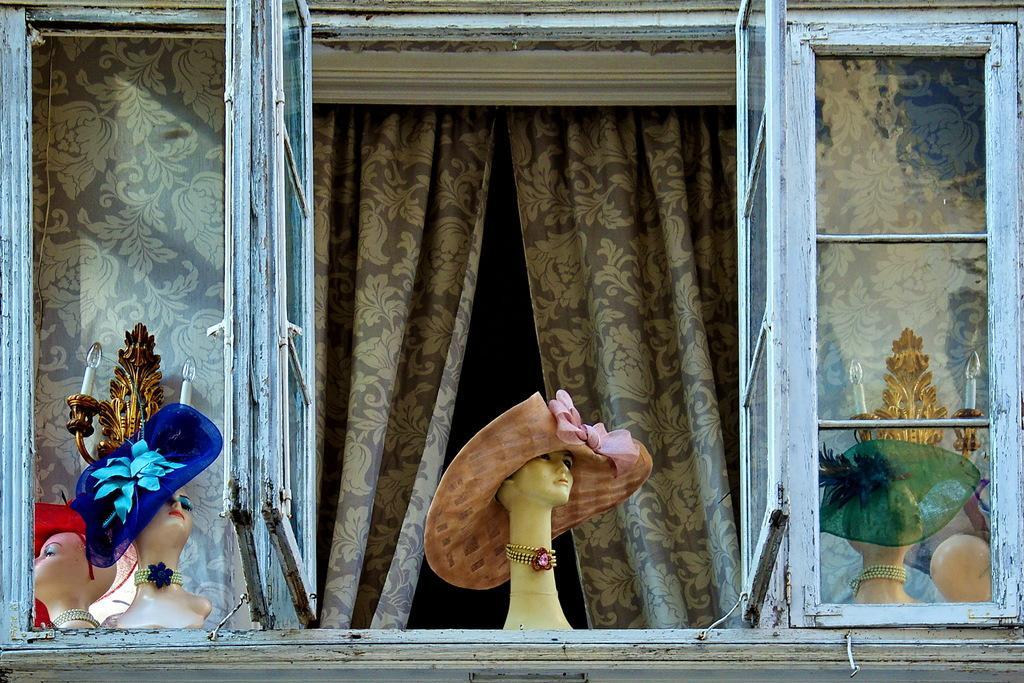Please provide a concise description of this image. In this picture we can see few mannequins, caps, lights and curtains, also we can find few metal rods. 